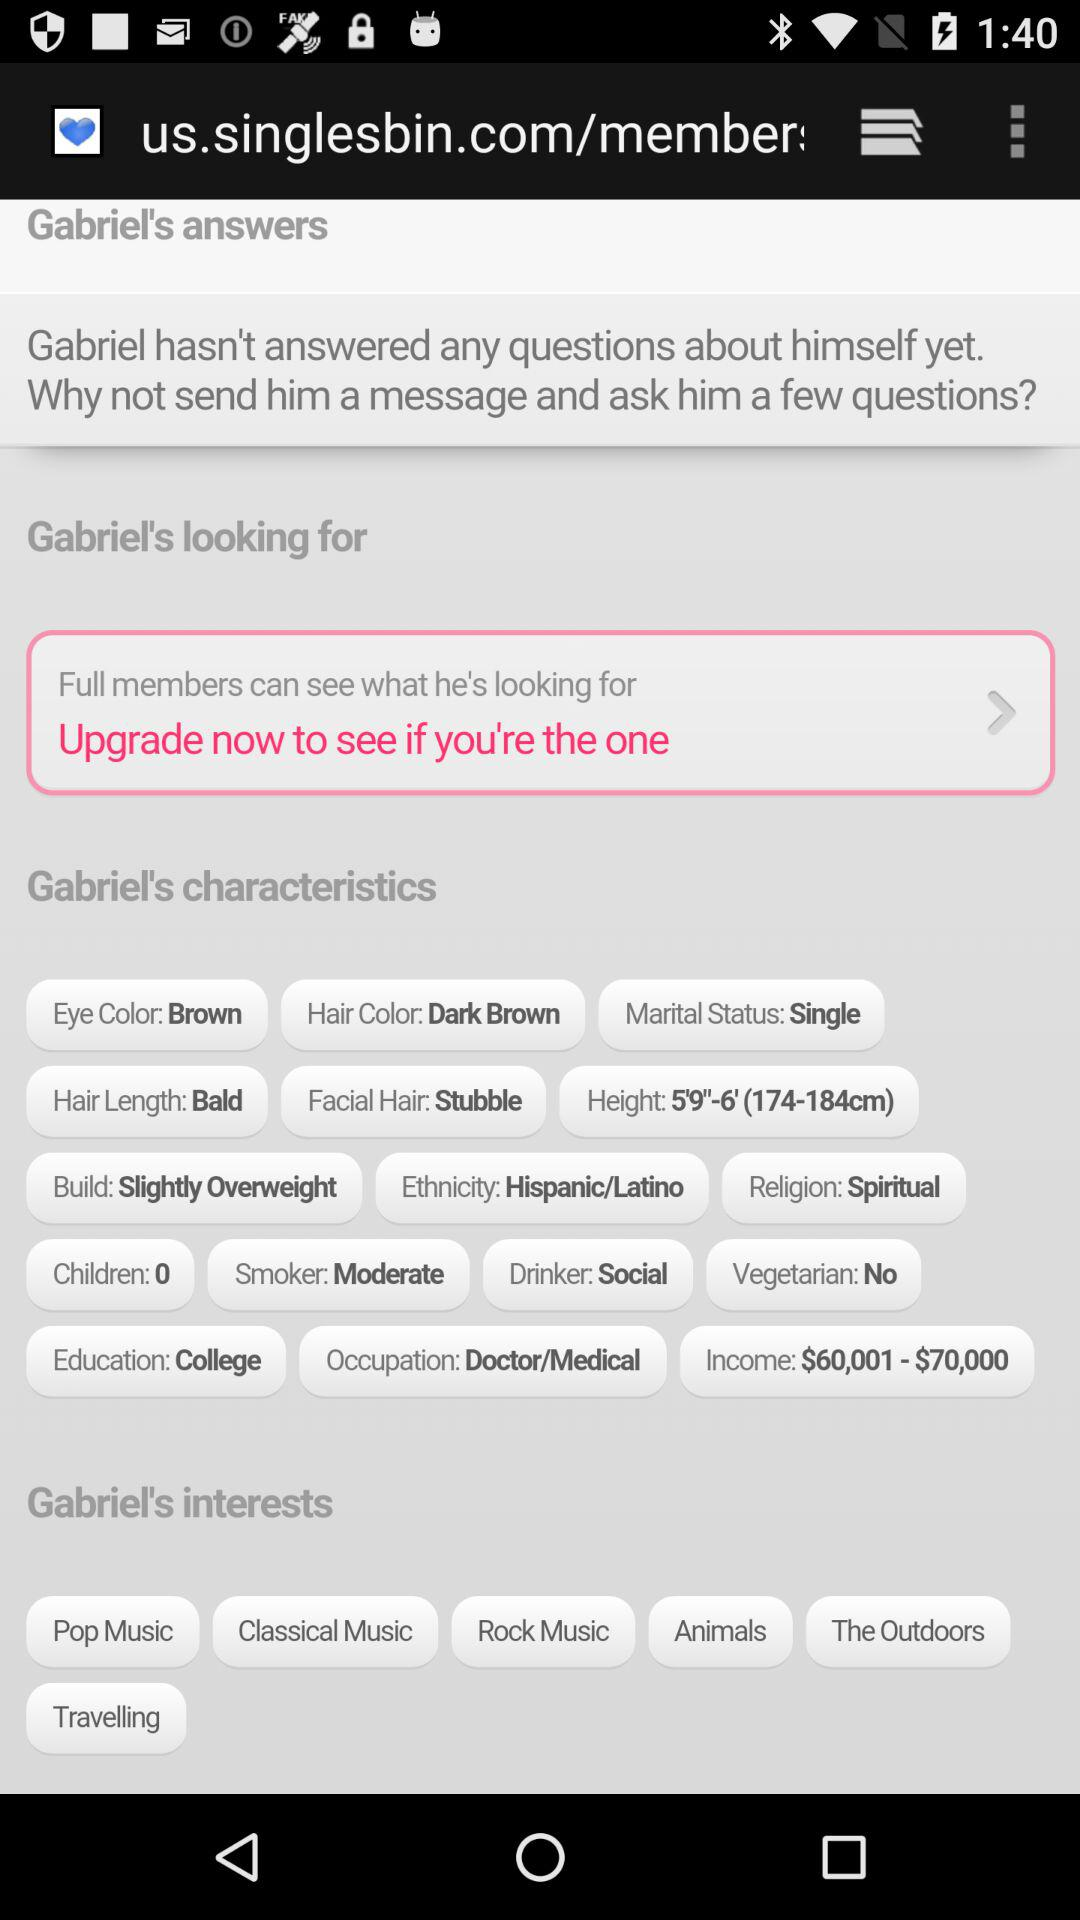What is the email address given? The email address is appcrawler6@gmail.com. 